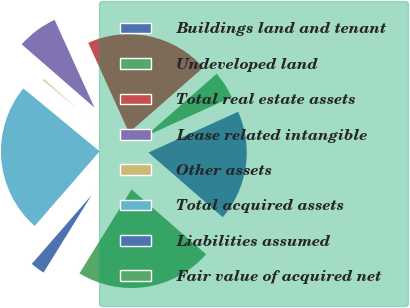<chart> <loc_0><loc_0><loc_500><loc_500><pie_chart><fcel>Buildings land and tenant<fcel>Undeveloped land<fcel>Total real estate assets<fcel>Lease related intangible<fcel>Other assets<fcel>Total acquired assets<fcel>Liabilities assumed<fcel>Fair value of acquired net<nl><fcel>18.18%<fcel>4.68%<fcel>20.32%<fcel>6.82%<fcel>0.41%<fcel>24.59%<fcel>2.55%<fcel>22.45%<nl></chart> 